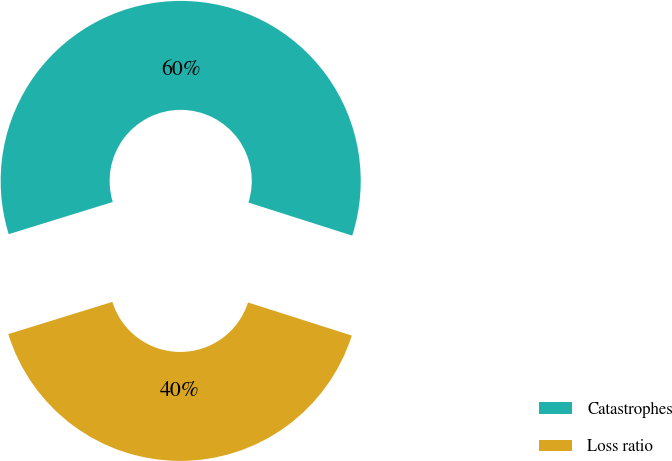<chart> <loc_0><loc_0><loc_500><loc_500><pie_chart><fcel>Catastrophes<fcel>Loss ratio<nl><fcel>59.69%<fcel>40.31%<nl></chart> 